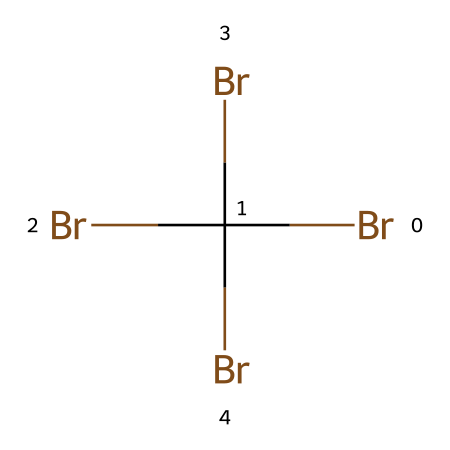What is the total number of bromine atoms in this chemical? There are four bromine atoms in the chemical structure represented by BrC(Br)(Br)Br. This can be determined by counting each "Br" in the SMILES representation, as well as considering the carbon's connectivity which indicates that these bromine atoms are all connected to the carbon atom.
Answer: four How many bonds does the carbon atom have? The carbon atom in this structure is bonded to four bromine atoms and has four total single bonds. Each bromine connects to the carbon atom, contributing to its tetravalent nature (form of carbon).
Answer: four What type of chemical compound is represented by this structure? The presence of multiple bromine atoms bonded to a carbon suggests that this is a brominated compound, specifically a brominated flame retardant used in electronics. This identification is crucial as it indicates its intended use in safety applications.
Answer: brominated compound Which element has the highest electronegativity in this structure? In the bromine-based flame retardant shown by the SMILES, bromine is the only non-metal present, and it is known for having a high electronegativity compared to carbon. Therefore, bromine would be the answer here.
Answer: bromine Why might brominated flame retardants be used in electronics? Brominated flame retardants are used in electronics due to their effectiveness in reducing flammability of materials, protecting against ignition, and improving fire safety in electronic devices. The multiple bromine atoms in the structure imply strong flame-retardant properties.
Answer: fire safety 